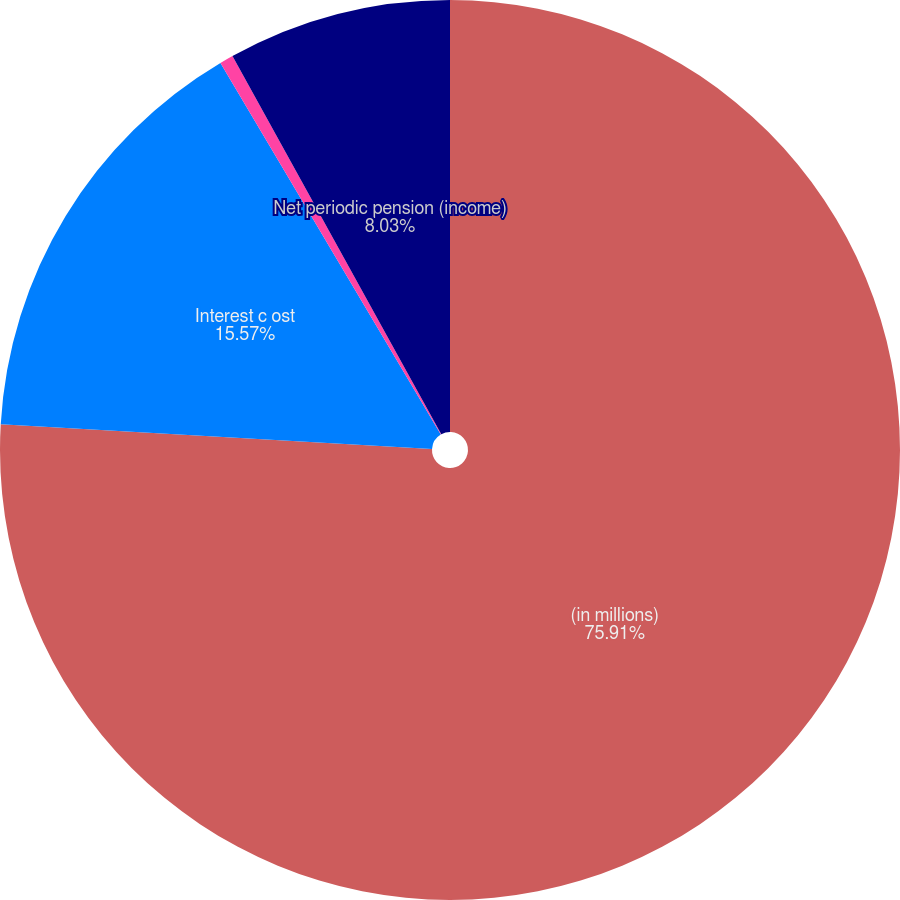Convert chart. <chart><loc_0><loc_0><loc_500><loc_500><pie_chart><fcel>(in millions)<fcel>Interest c ost<fcel>Amortization of actuarial loss<fcel>Net periodic pension (income)<nl><fcel>75.91%<fcel>15.57%<fcel>0.49%<fcel>8.03%<nl></chart> 